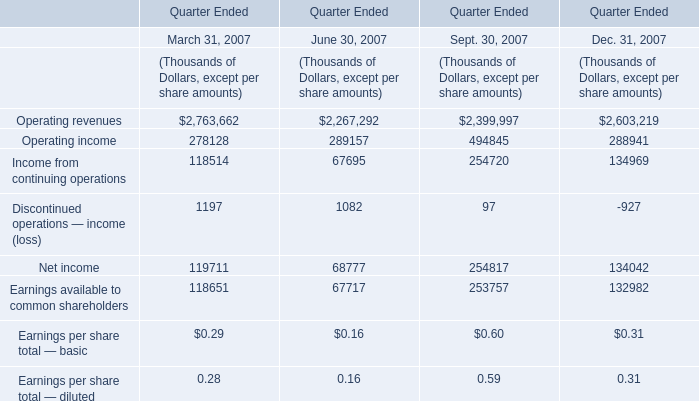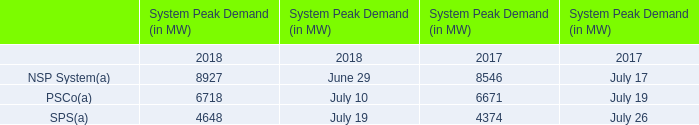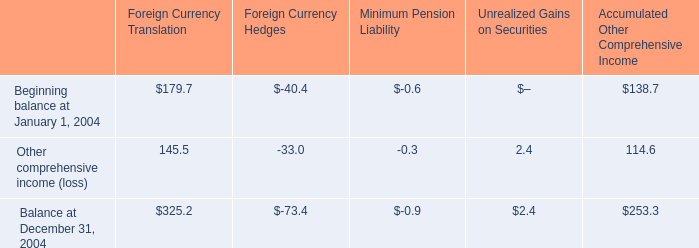In which years is Operating revenues greater than Operating income 
Answer: March 31, 2007 June 30, 2007 Sept. 30, 2007 Dec. 31, 2007. 